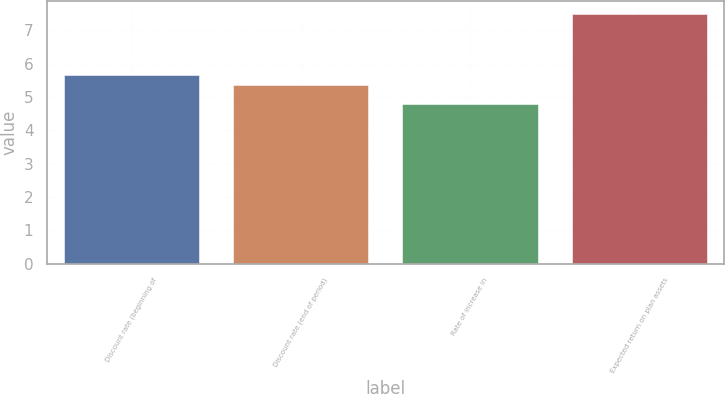Convert chart to OTSL. <chart><loc_0><loc_0><loc_500><loc_500><bar_chart><fcel>Discount rate (beginning of<fcel>Discount rate (end of period)<fcel>Rate of increase in<fcel>Expected return on plan assets<nl><fcel>5.65<fcel>5.35<fcel>4.8<fcel>7.5<nl></chart> 